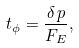<formula> <loc_0><loc_0><loc_500><loc_500>t _ { \phi } = \frac { \delta \, p } { F _ { E } } ,</formula> 